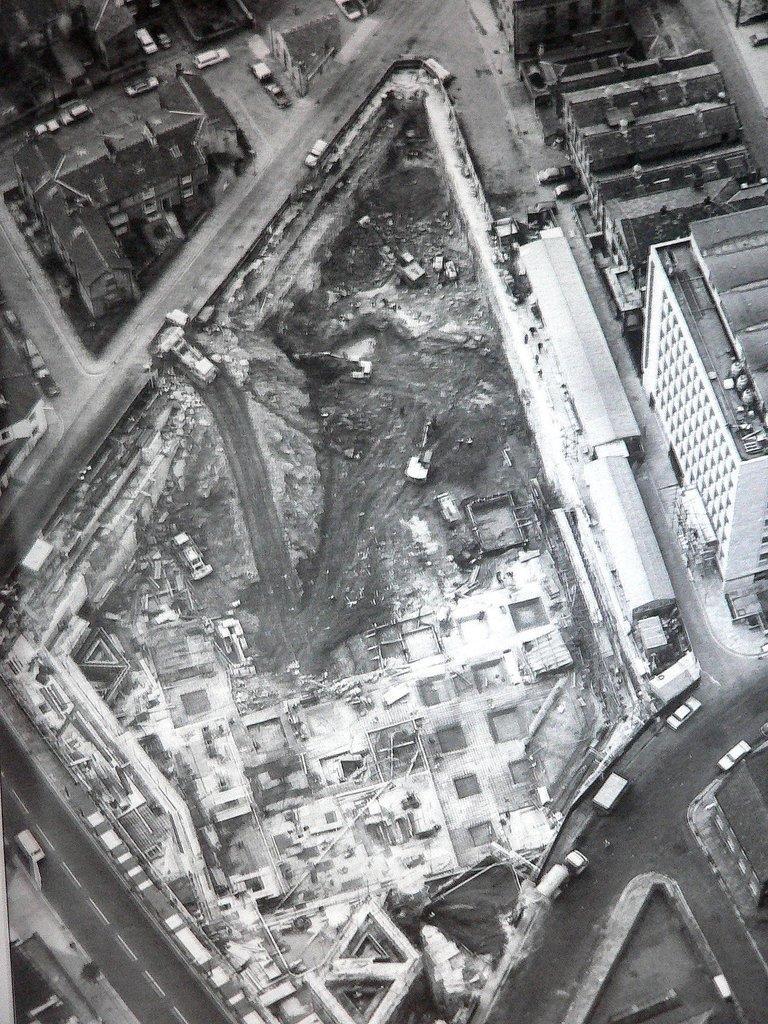How would you summarize this image in a sentence or two? In this picture I can observe roads. There are some vehicles moving on the roads. I can observe some buildings in this picture. 